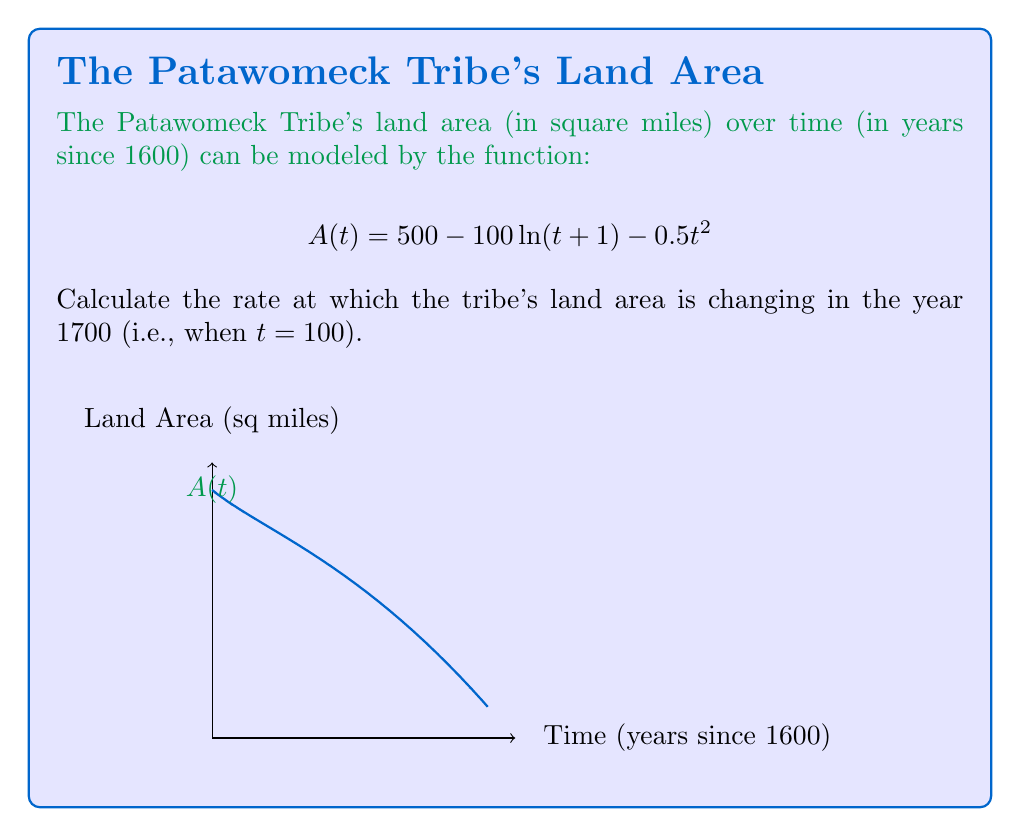Could you help me with this problem? To find the rate of change of the land area at t = 100, we need to calculate the derivative of A(t) and then evaluate it at t = 100.

Step 1: Find the derivative of A(t).
$$A(t) = 500 - 100\ln(t+1) - 0.5t^2$$
$$A'(t) = -100 \cdot \frac{1}{t+1} - t$$

Step 2: Evaluate A'(t) at t = 100.
$$A'(100) = -100 \cdot \frac{1}{101} - 100$$
$$= -\frac{100}{101} - 100$$
$$= -\frac{100}{101} - \frac{10100}{101}$$
$$= -\frac{10200}{101}$$
$$\approx -100.99$$

The negative value indicates that the land area is decreasing.
Answer: $-\frac{10200}{101}$ sq miles/year 